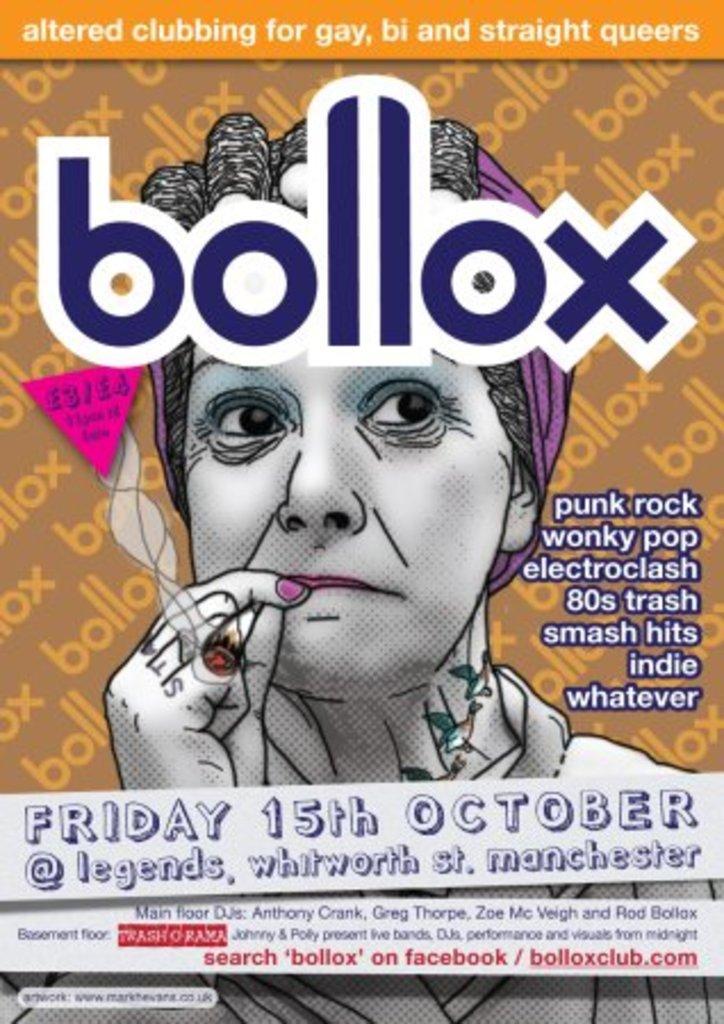Can you describe this image briefly? In the picture we can see a poster of a woman smoking, on it we can see name as blocks and under the image we can see Friday 15th October, at legends, Manchester. 